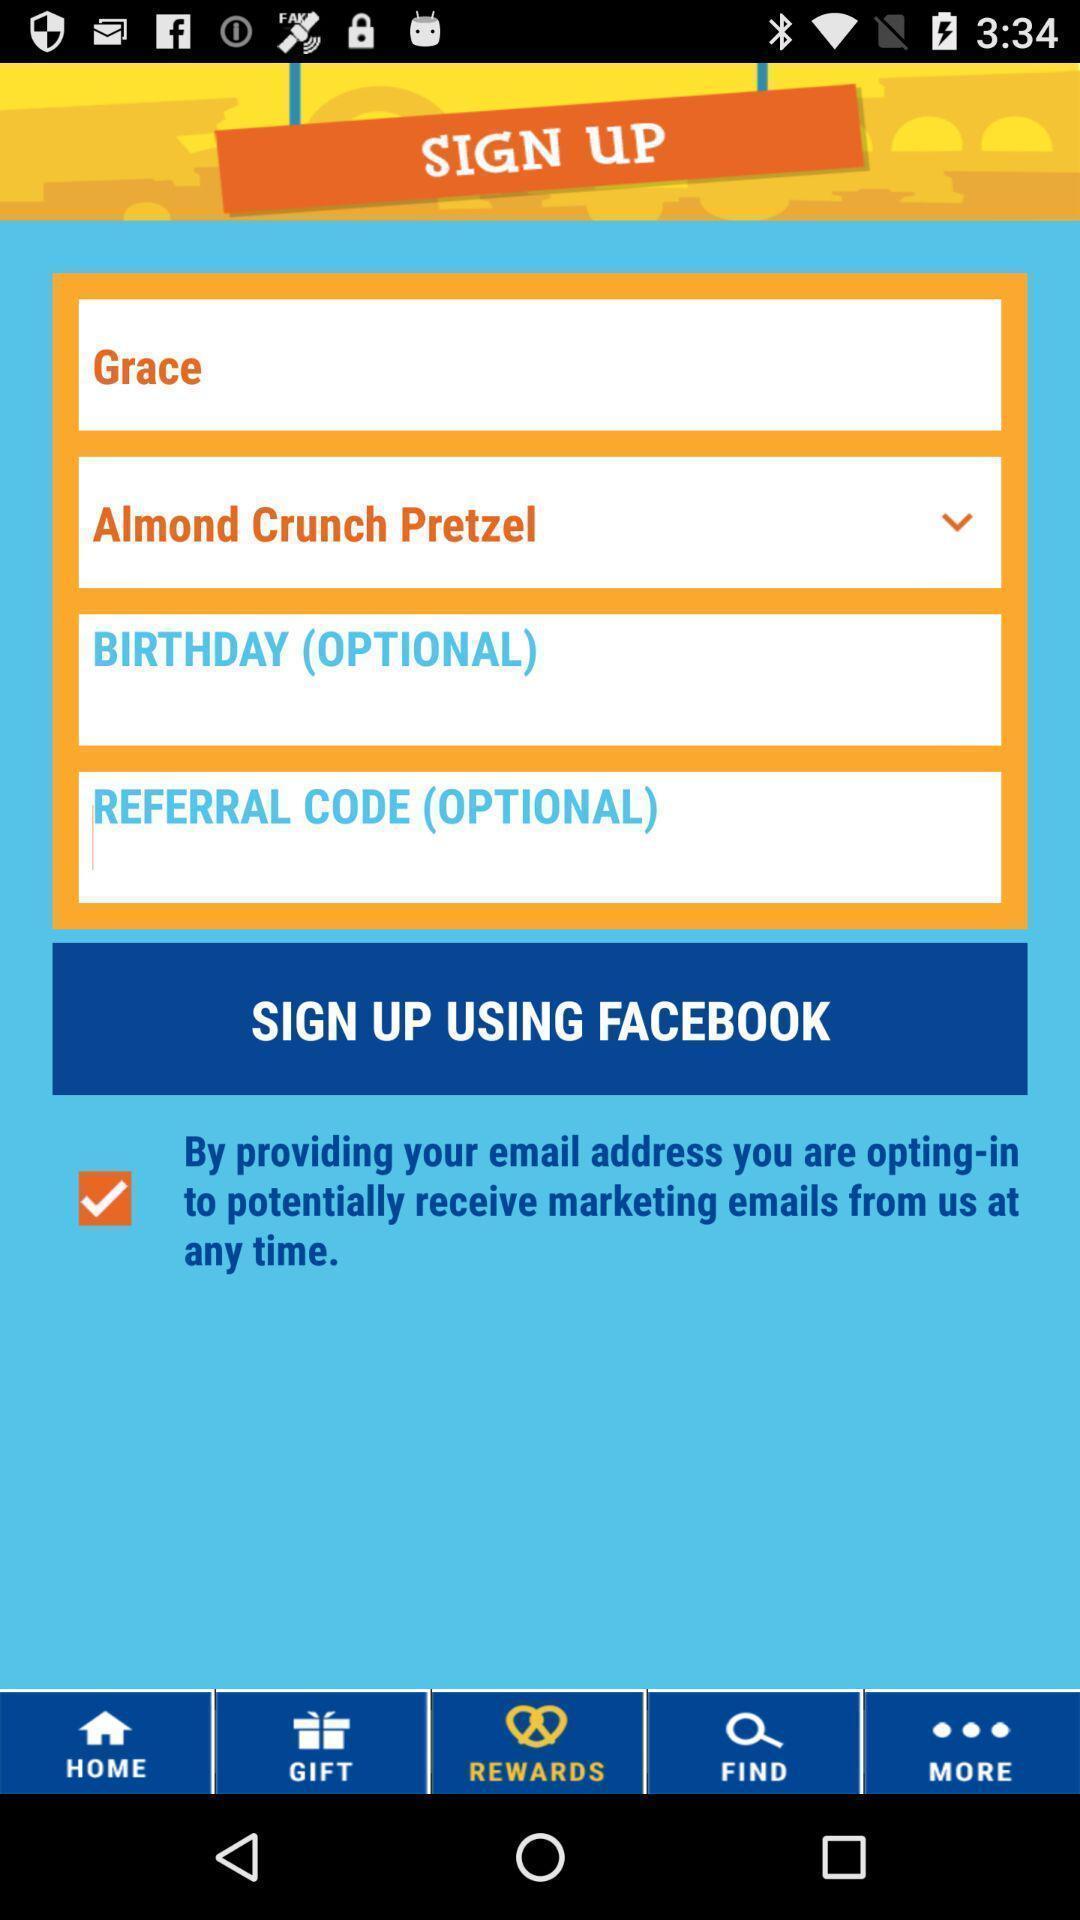Describe the visual elements of this screenshot. Sign up page to get in to the application. 